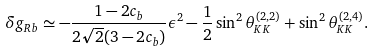<formula> <loc_0><loc_0><loc_500><loc_500>\delta g _ { R b } \simeq - \frac { 1 - 2 c _ { b } } { 2 \sqrt { 2 } ( 3 - 2 c _ { b } ) } \epsilon ^ { 2 } - \frac { 1 } { 2 } \sin ^ { 2 } \theta ^ { ( 2 , 2 ) } _ { K K } + \sin ^ { 2 } \theta ^ { ( 2 , 4 ) } _ { K K } .</formula> 